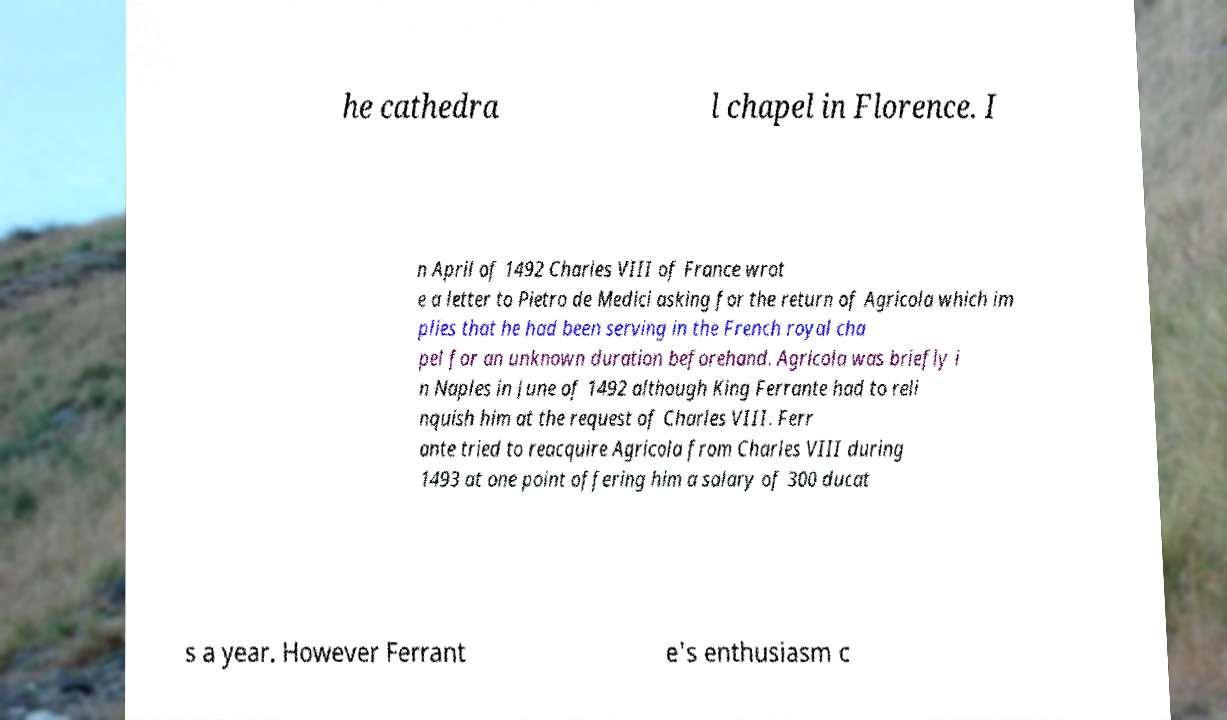Could you assist in decoding the text presented in this image and type it out clearly? he cathedra l chapel in Florence. I n April of 1492 Charles VIII of France wrot e a letter to Pietro de Medici asking for the return of Agricola which im plies that he had been serving in the French royal cha pel for an unknown duration beforehand. Agricola was briefly i n Naples in June of 1492 although King Ferrante had to reli nquish him at the request of Charles VIII. Ferr ante tried to reacquire Agricola from Charles VIII during 1493 at one point offering him a salary of 300 ducat s a year. However Ferrant e's enthusiasm c 